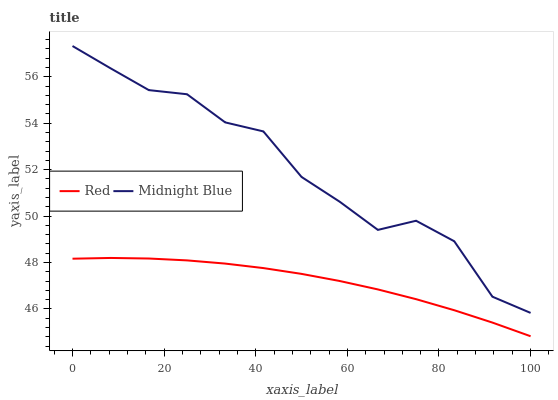Does Red have the maximum area under the curve?
Answer yes or no. No. Is Red the roughest?
Answer yes or no. No. Does Red have the highest value?
Answer yes or no. No. Is Red less than Midnight Blue?
Answer yes or no. Yes. Is Midnight Blue greater than Red?
Answer yes or no. Yes. Does Red intersect Midnight Blue?
Answer yes or no. No. 